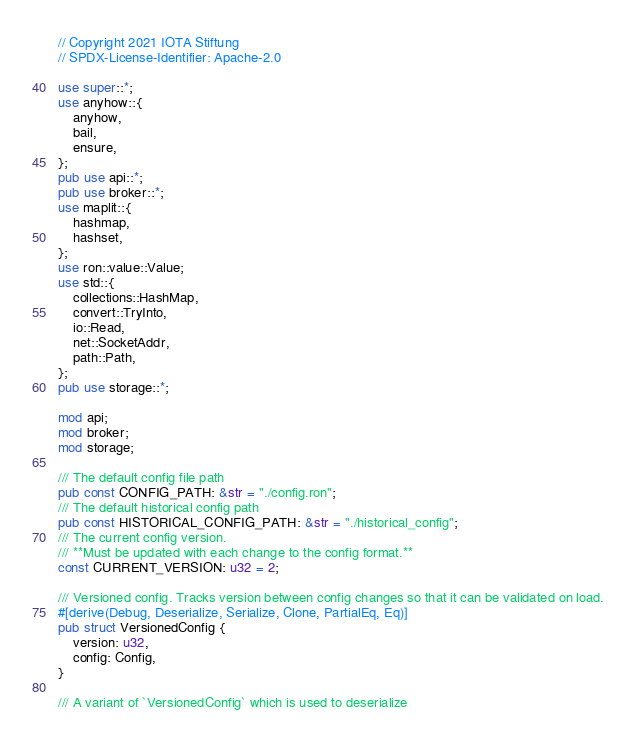<code> <loc_0><loc_0><loc_500><loc_500><_Rust_>// Copyright 2021 IOTA Stiftung
// SPDX-License-Identifier: Apache-2.0

use super::*;
use anyhow::{
    anyhow,
    bail,
    ensure,
};
pub use api::*;
pub use broker::*;
use maplit::{
    hashmap,
    hashset,
};
use ron::value::Value;
use std::{
    collections::HashMap,
    convert::TryInto,
    io::Read,
    net::SocketAddr,
    path::Path,
};
pub use storage::*;

mod api;
mod broker;
mod storage;

/// The default config file path
pub const CONFIG_PATH: &str = "./config.ron";
/// The default historical config path
pub const HISTORICAL_CONFIG_PATH: &str = "./historical_config";
/// The current config version.
/// **Must be updated with each change to the config format.**
const CURRENT_VERSION: u32 = 2;

/// Versioned config. Tracks version between config changes so that it can be validated on load.
#[derive(Debug, Deserialize, Serialize, Clone, PartialEq, Eq)]
pub struct VersionedConfig {
    version: u32,
    config: Config,
}

/// A variant of `VersionedConfig` which is used to deserialize</code> 